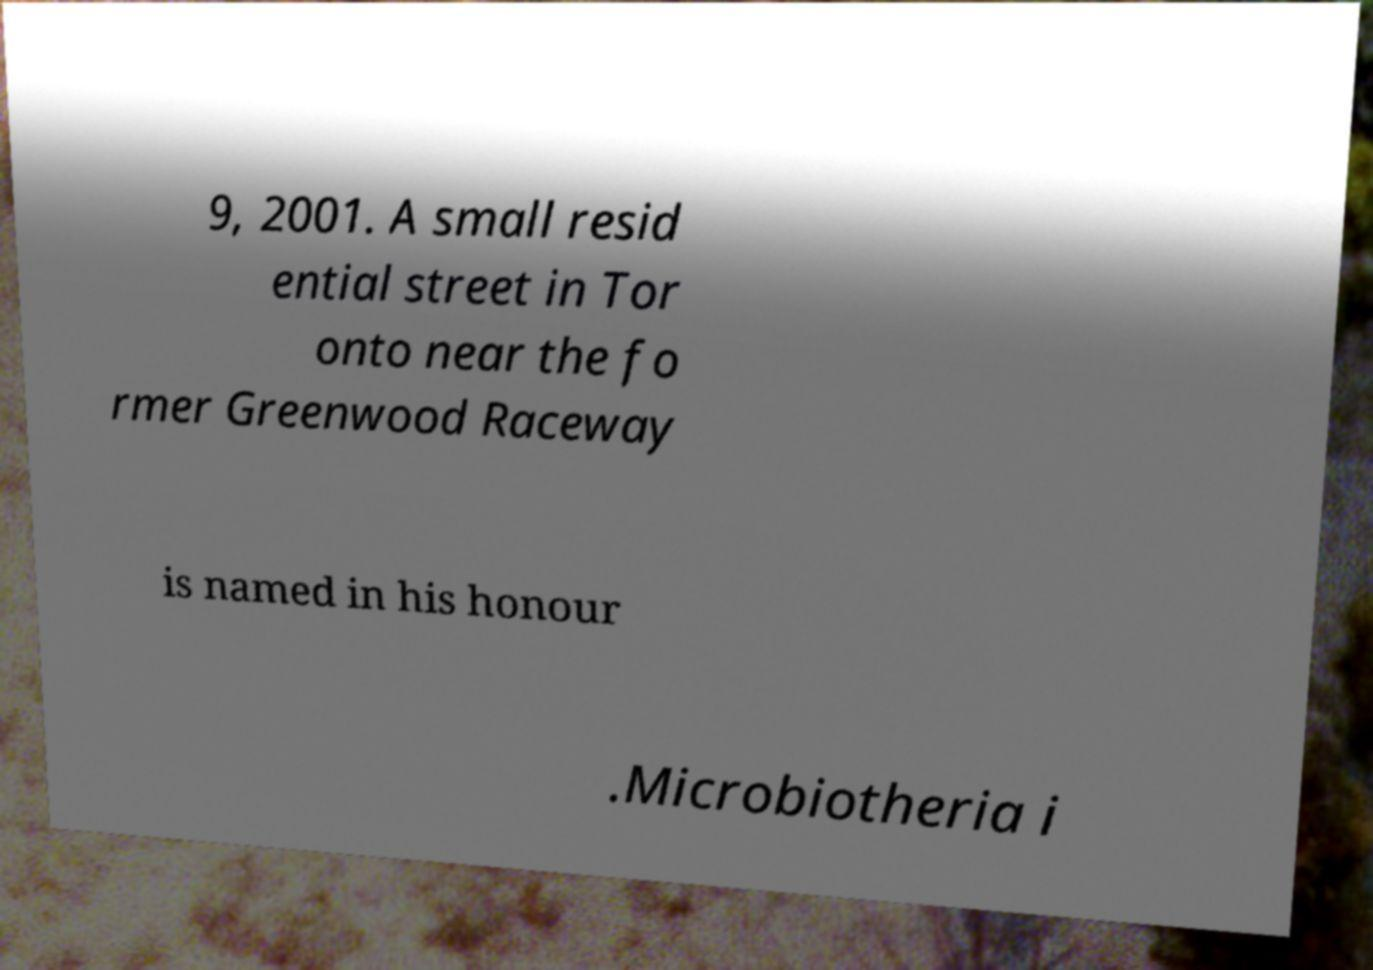Could you assist in decoding the text presented in this image and type it out clearly? 9, 2001. A small resid ential street in Tor onto near the fo rmer Greenwood Raceway is named in his honour .Microbiotheria i 